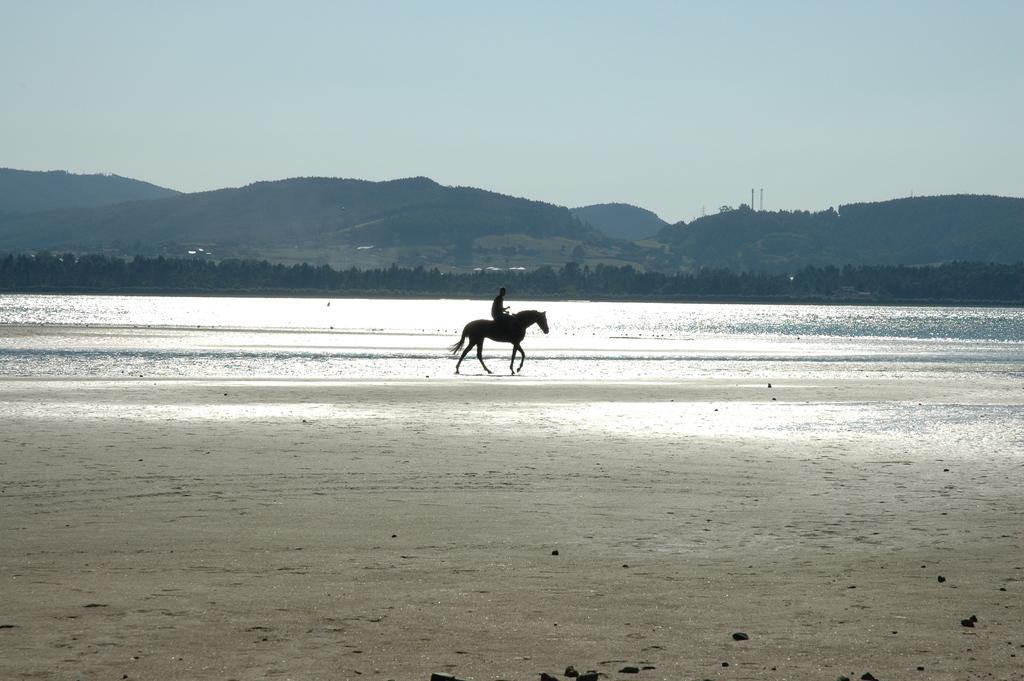What is the person in the image doing? The person is sitting on a horse in the image. What can be seen in the background of the image? There is a sea, trees, hills, and the sky visible in the background of the image. What is the terrain like at the bottom of the image? There is a seashore at the bottom of the image. Where is the nearest hospital to the person sitting on the horse in the image? There is no information about the location of a hospital in the image, so it cannot be determined. 